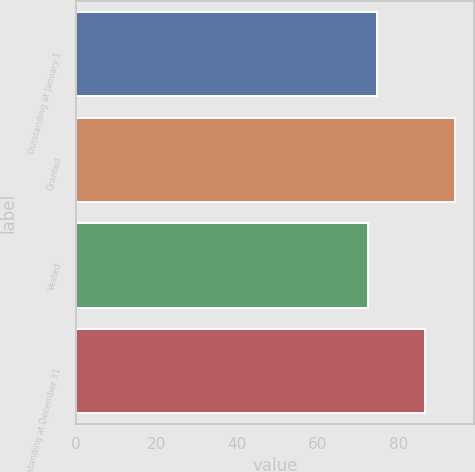Convert chart to OTSL. <chart><loc_0><loc_0><loc_500><loc_500><bar_chart><fcel>Outstanding at January 1<fcel>Granted<fcel>Vested<fcel>Outstanding at December 31<nl><fcel>74.62<fcel>94.11<fcel>72.46<fcel>86.6<nl></chart> 